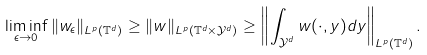<formula> <loc_0><loc_0><loc_500><loc_500>\liminf _ { \epsilon \rightarrow 0 } \| w _ { \epsilon } \| _ { { L } ^ { p } ( \mathbb { T } ^ { d } ) } \geq \| w \| _ { { L } ^ { p } ( \mathbb { T } ^ { d } \times \mathcal { Y } ^ { d } ) } \geq \left \| \int _ { \mathcal { Y } ^ { d } } w ( \cdot , y ) d y \right \| _ { { L } ^ { p } ( \mathbb { T } ^ { d } ) } .</formula> 